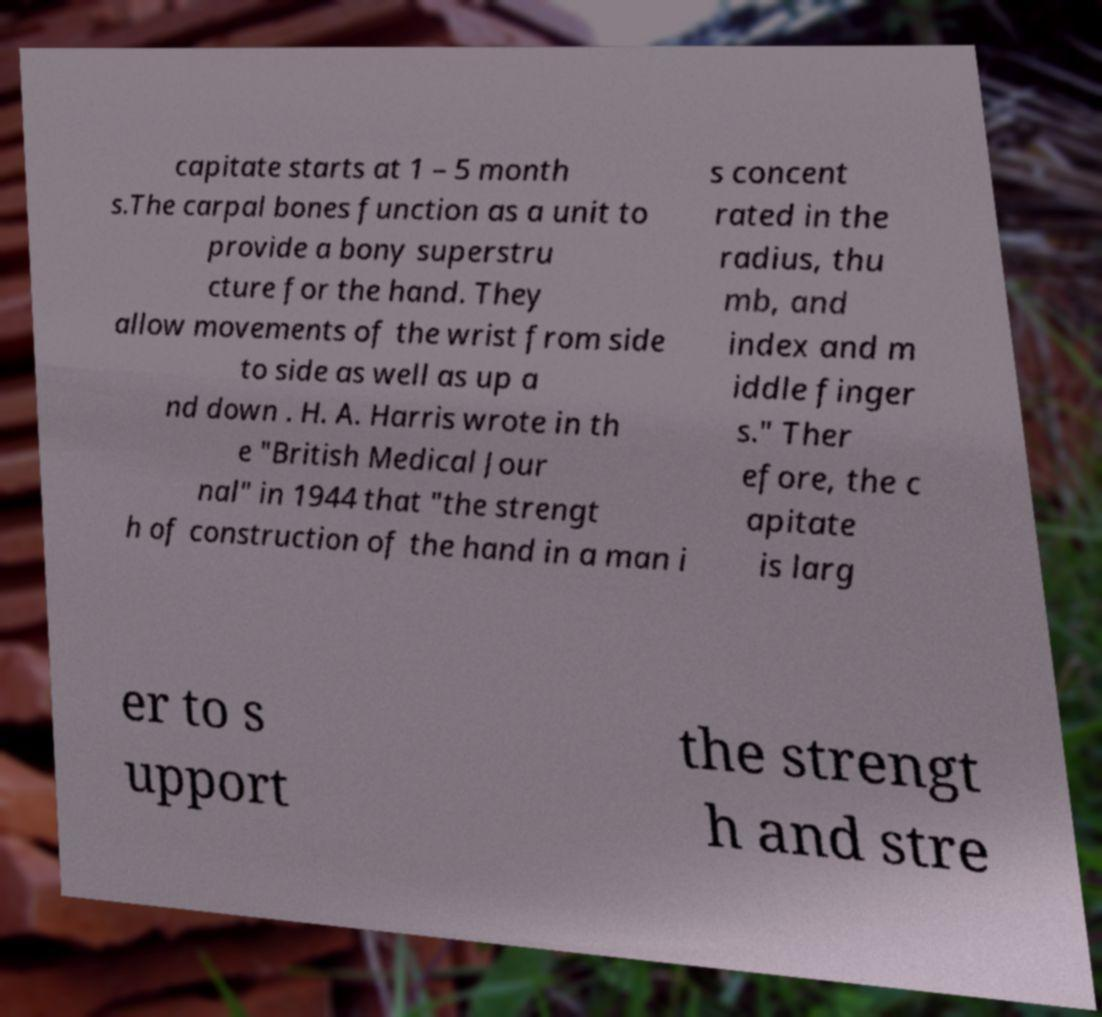Please identify and transcribe the text found in this image. capitate starts at 1 – 5 month s.The carpal bones function as a unit to provide a bony superstru cture for the hand. They allow movements of the wrist from side to side as well as up a nd down . H. A. Harris wrote in th e "British Medical Jour nal" in 1944 that "the strengt h of construction of the hand in a man i s concent rated in the radius, thu mb, and index and m iddle finger s." Ther efore, the c apitate is larg er to s upport the strengt h and stre 